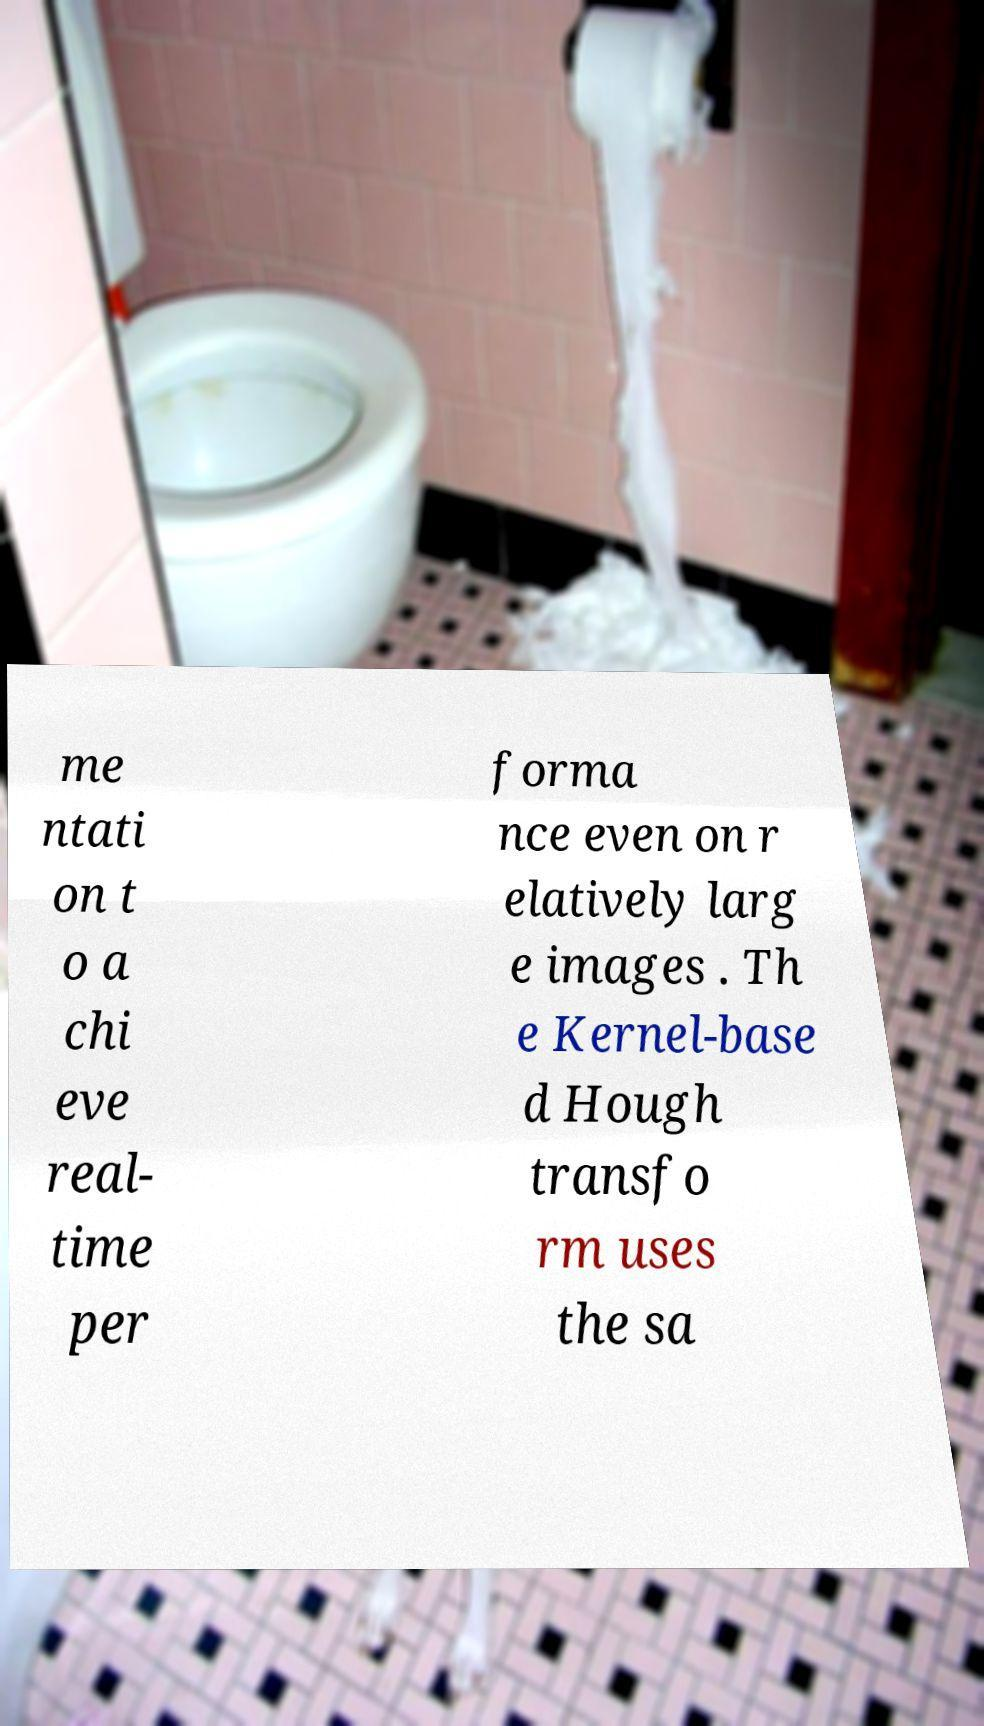There's text embedded in this image that I need extracted. Can you transcribe it verbatim? me ntati on t o a chi eve real- time per forma nce even on r elatively larg e images . Th e Kernel-base d Hough transfo rm uses the sa 